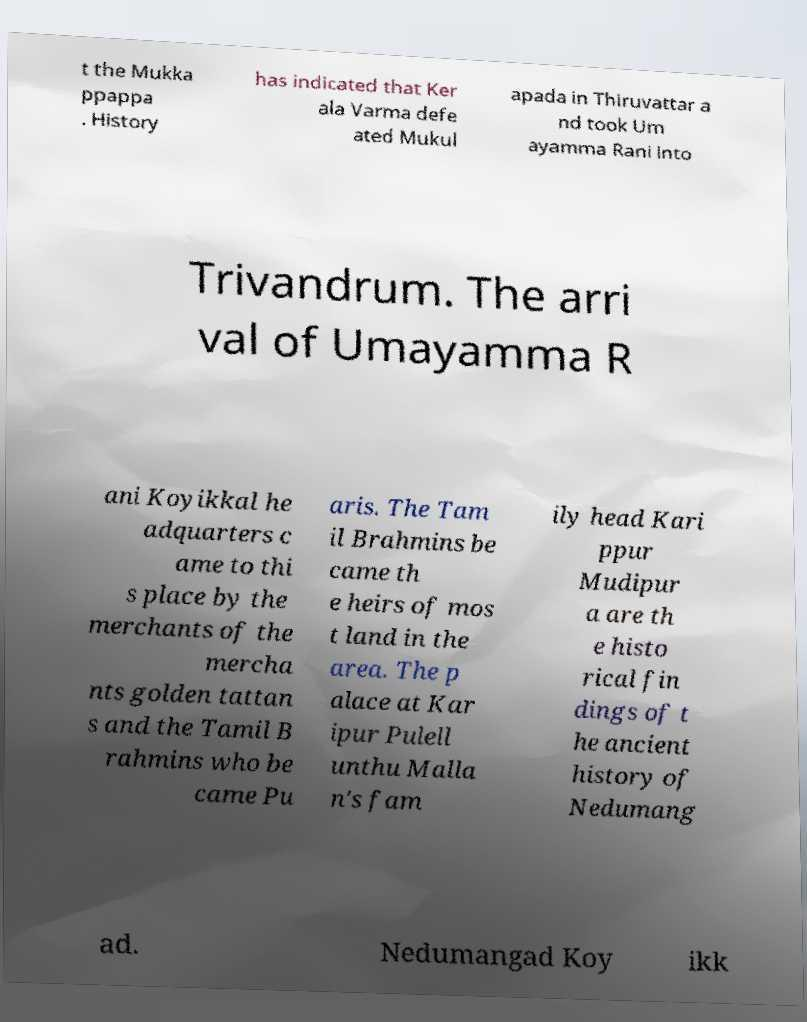Can you read and provide the text displayed in the image?This photo seems to have some interesting text. Can you extract and type it out for me? t the Mukka ppappa . History has indicated that Ker ala Varma defe ated Mukul apada in Thiruvattar a nd took Um ayamma Rani into Trivandrum. The arri val of Umayamma R ani Koyikkal he adquarters c ame to thi s place by the merchants of the mercha nts golden tattan s and the Tamil B rahmins who be came Pu aris. The Tam il Brahmins be came th e heirs of mos t land in the area. The p alace at Kar ipur Pulell unthu Malla n's fam ily head Kari ppur Mudipur a are th e histo rical fin dings of t he ancient history of Nedumang ad. Nedumangad Koy ikk 